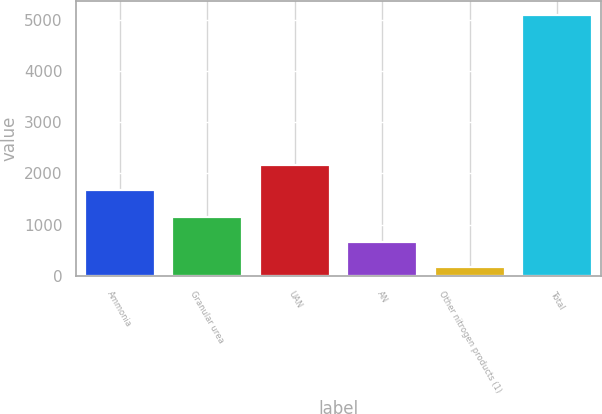Convert chart. <chart><loc_0><loc_0><loc_500><loc_500><bar_chart><fcel>Ammonia<fcel>Granular urea<fcel>UAN<fcel>AN<fcel>Other nitrogen products (1)<fcel>Total<nl><fcel>1677.6<fcel>1152.6<fcel>2170.6<fcel>659.6<fcel>166.6<fcel>5096.6<nl></chart> 